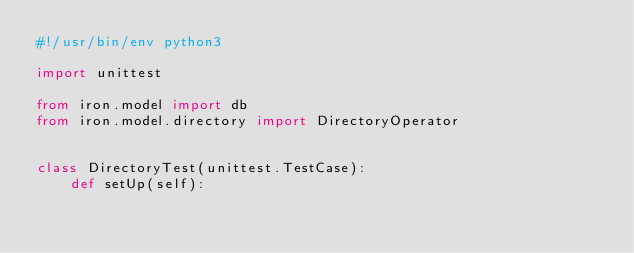<code> <loc_0><loc_0><loc_500><loc_500><_Python_>#!/usr/bin/env python3

import unittest

from iron.model import db
from iron.model.directory import DirectoryOperator


class DirectoryTest(unittest.TestCase):
    def setUp(self):</code> 